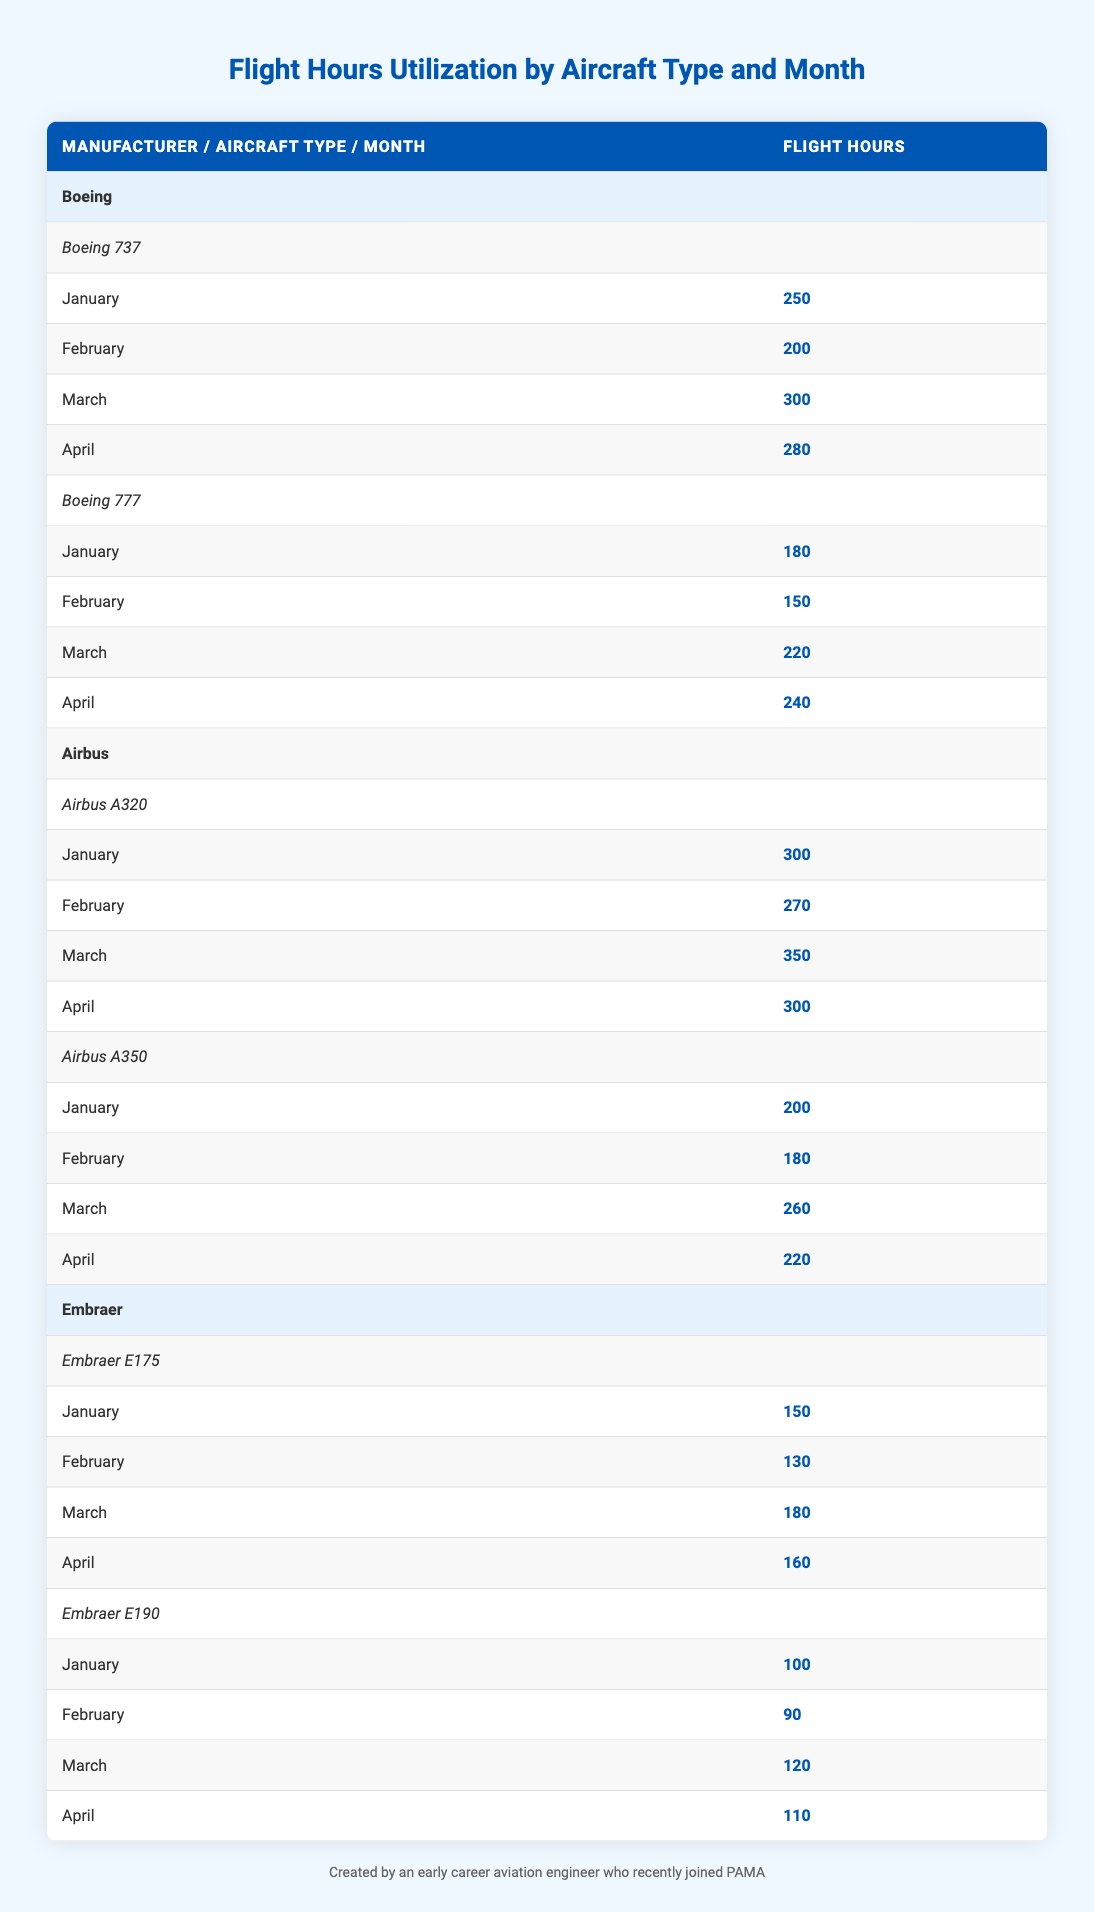What are the total flight hours for the Boeing 737 in March? The Boeing 737 has a flight hour value of 300 in March. Since this is a retrieval question, we simply need to look directly at the corresponding row in the table under the Boeing 737 aircraft type.
Answer: 300 What was the highest flight hour recorded for any aircraft type in January? The table shows that the Airbus A320 had the highest flight hour of 300 in January, compared to the other aircraft types listed. We can find this by comparing the January values for all the aircraft.
Answer: 300 How many total flight hours were utilized by Airbus aircraft in April? To find the total flight hours for Airbus in April, we must sum the flight hours for both the Airbus A320 (300) and Airbus A350 (220) for that month. Therefore, we calculate 300 + 220 = 520.
Answer: 520 Did the Embraer E190 have more flight hours than the Embraer E175 in February? The table shows that the Embraer E175 had 130 flight hours in February, while the Embraer E190 had 90 flight hours. Therefore, the statement is true because 130 is greater than 90.
Answer: No Which aircraft had the least flight hours in March? To answer this, we compare the flight hours for all aircraft types in March: Boeing 737 (300), Boeing 777 (220), Airbus A320 (350), Airbus A350 (260), Embraer E175 (180), and Embraer E190 (120). The Embraer E190 had the least with 120 flight hours.
Answer: Embraer E190 What is the average flight hour utilization for all Boeing aircraft in February? The total flight hours for Boeing in February are calculated by adding the Boeing 737 hours (200) and Boeing 777 hours (150), resulting in 350. There are 2 data points (Boeing 737 and Boeing 777), so we divide 350 by 2 to get the average: 350 / 2 = 175.
Answer: 175 Which month had the highest total flight hours for Airbus aircraft combined? We need to sum the flight hours for Airbus in each month. In January (300 + 200 = 500), February (270 + 180 = 450), March (350 + 260 = 610), April (300 + 220 = 520). The highest total is in March (610).
Answer: March Is the flight hour utilization for the Boeing 777 higher in March than in April? The flight hours for Boeing 777 are 220 in March and 240 in April. Since 240 is greater than 220, the statement is false.
Answer: No 